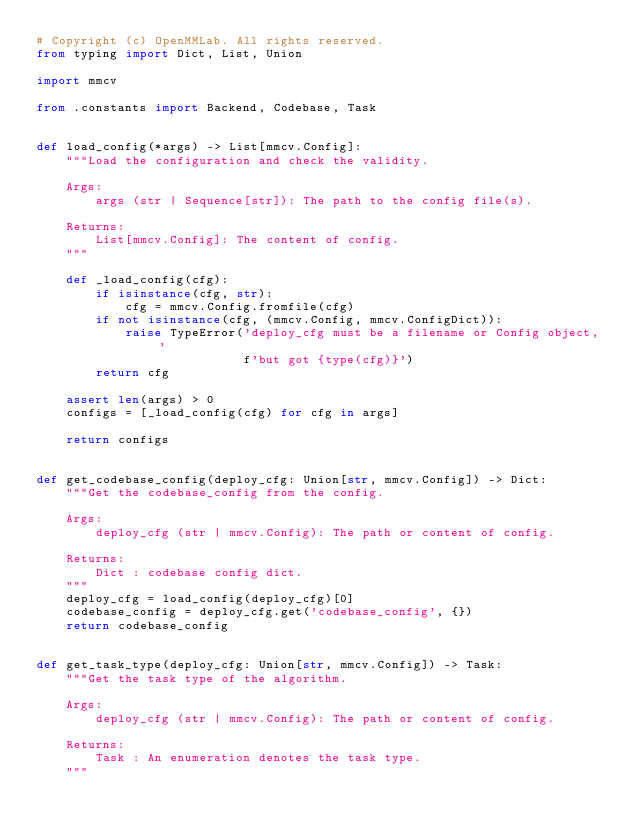Convert code to text. <code><loc_0><loc_0><loc_500><loc_500><_Python_># Copyright (c) OpenMMLab. All rights reserved.
from typing import Dict, List, Union

import mmcv

from .constants import Backend, Codebase, Task


def load_config(*args) -> List[mmcv.Config]:
    """Load the configuration and check the validity.

    Args:
        args (str | Sequence[str]): The path to the config file(s).

    Returns:
        List[mmcv.Config]: The content of config.
    """

    def _load_config(cfg):
        if isinstance(cfg, str):
            cfg = mmcv.Config.fromfile(cfg)
        if not isinstance(cfg, (mmcv.Config, mmcv.ConfigDict)):
            raise TypeError('deploy_cfg must be a filename or Config object, '
                            f'but got {type(cfg)}')
        return cfg

    assert len(args) > 0
    configs = [_load_config(cfg) for cfg in args]

    return configs


def get_codebase_config(deploy_cfg: Union[str, mmcv.Config]) -> Dict:
    """Get the codebase_config from the config.

    Args:
        deploy_cfg (str | mmcv.Config): The path or content of config.

    Returns:
        Dict : codebase config dict.
    """
    deploy_cfg = load_config(deploy_cfg)[0]
    codebase_config = deploy_cfg.get('codebase_config', {})
    return codebase_config


def get_task_type(deploy_cfg: Union[str, mmcv.Config]) -> Task:
    """Get the task type of the algorithm.

    Args:
        deploy_cfg (str | mmcv.Config): The path or content of config.

    Returns:
        Task : An enumeration denotes the task type.
    """
</code> 